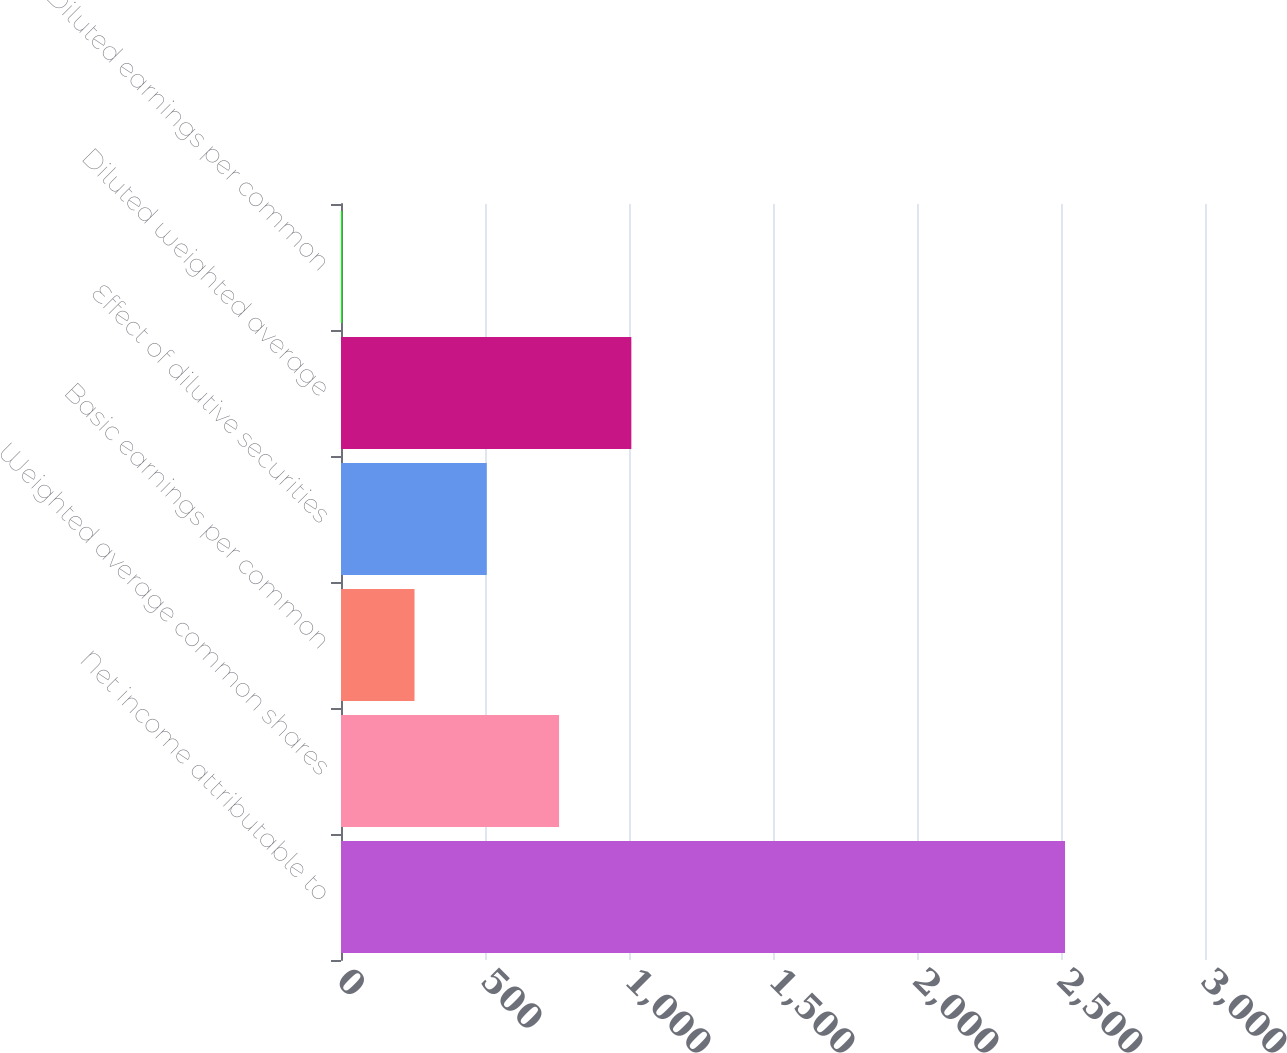Convert chart. <chart><loc_0><loc_0><loc_500><loc_500><bar_chart><fcel>Net income attributable to<fcel>Weighted average common shares<fcel>Basic earnings per common<fcel>Effect of dilutive securities<fcel>Diluted weighted average<fcel>Diluted earnings per common<nl><fcel>2514<fcel>757.17<fcel>255.21<fcel>506.19<fcel>1008.15<fcel>4.23<nl></chart> 